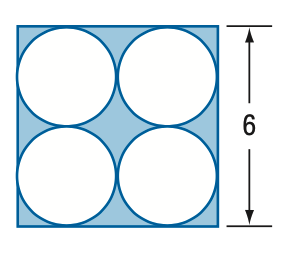Answer the mathemtical geometry problem and directly provide the correct option letter.
Question: Find the area of the shaded region. Round to the nearest tenth.
Choices: A: 7.1 B: 7.7 C: 21.9 D: 28.9 B 